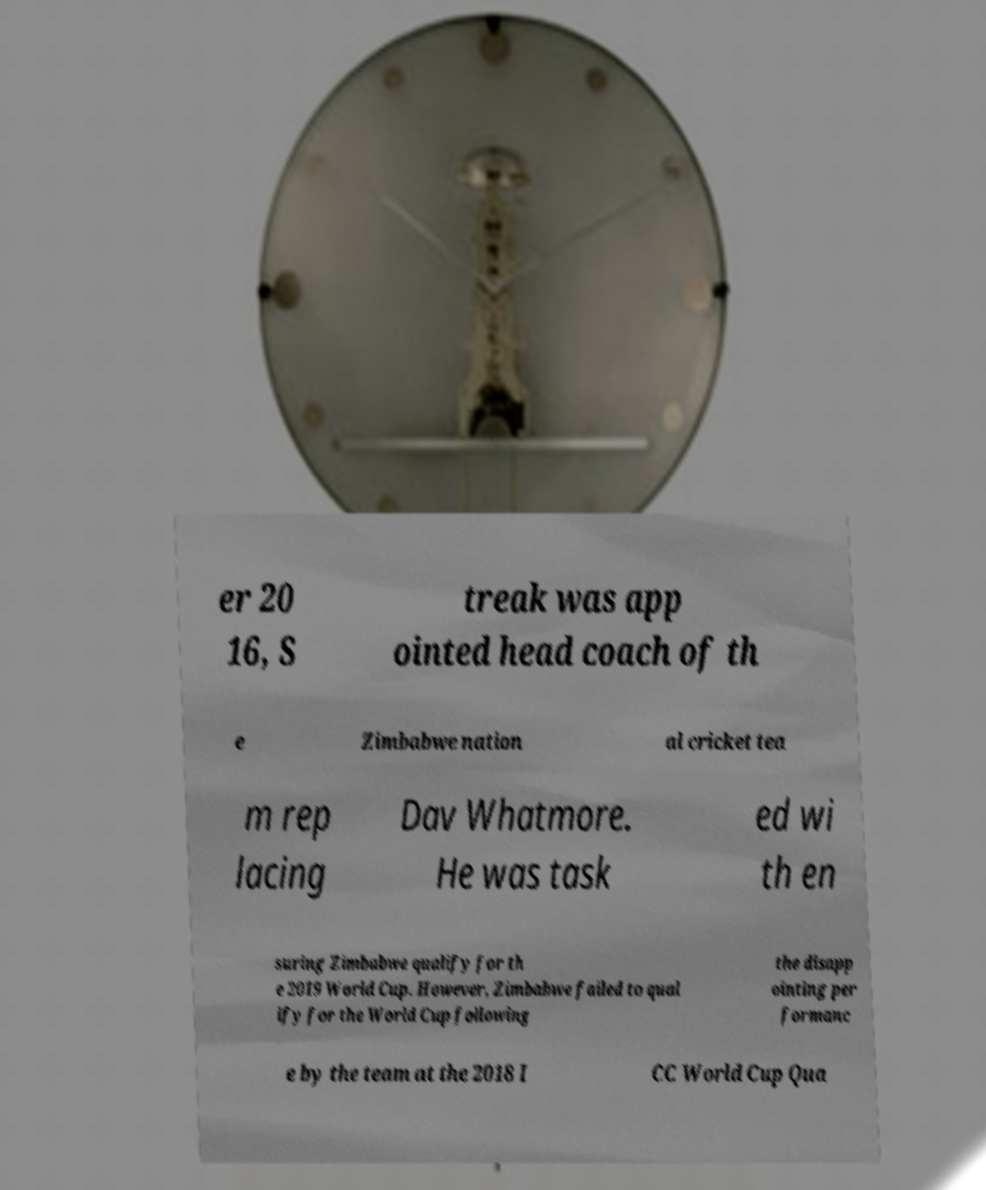I need the written content from this picture converted into text. Can you do that? er 20 16, S treak was app ointed head coach of th e Zimbabwe nation al cricket tea m rep lacing Dav Whatmore. He was task ed wi th en suring Zimbabwe qualify for th e 2019 World Cup. However, Zimbabwe failed to qual ify for the World Cup following the disapp ointing per formanc e by the team at the 2018 I CC World Cup Qua 